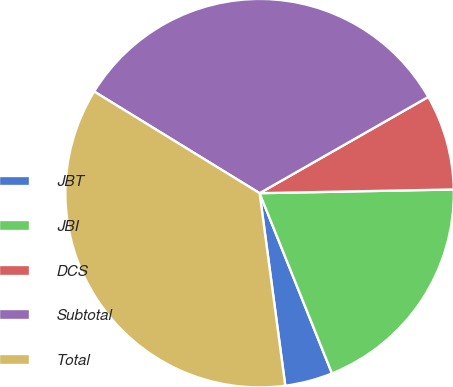Convert chart to OTSL. <chart><loc_0><loc_0><loc_500><loc_500><pie_chart><fcel>JBT<fcel>JBI<fcel>DCS<fcel>Subtotal<fcel>Total<nl><fcel>3.97%<fcel>19.23%<fcel>7.95%<fcel>32.98%<fcel>35.88%<nl></chart> 